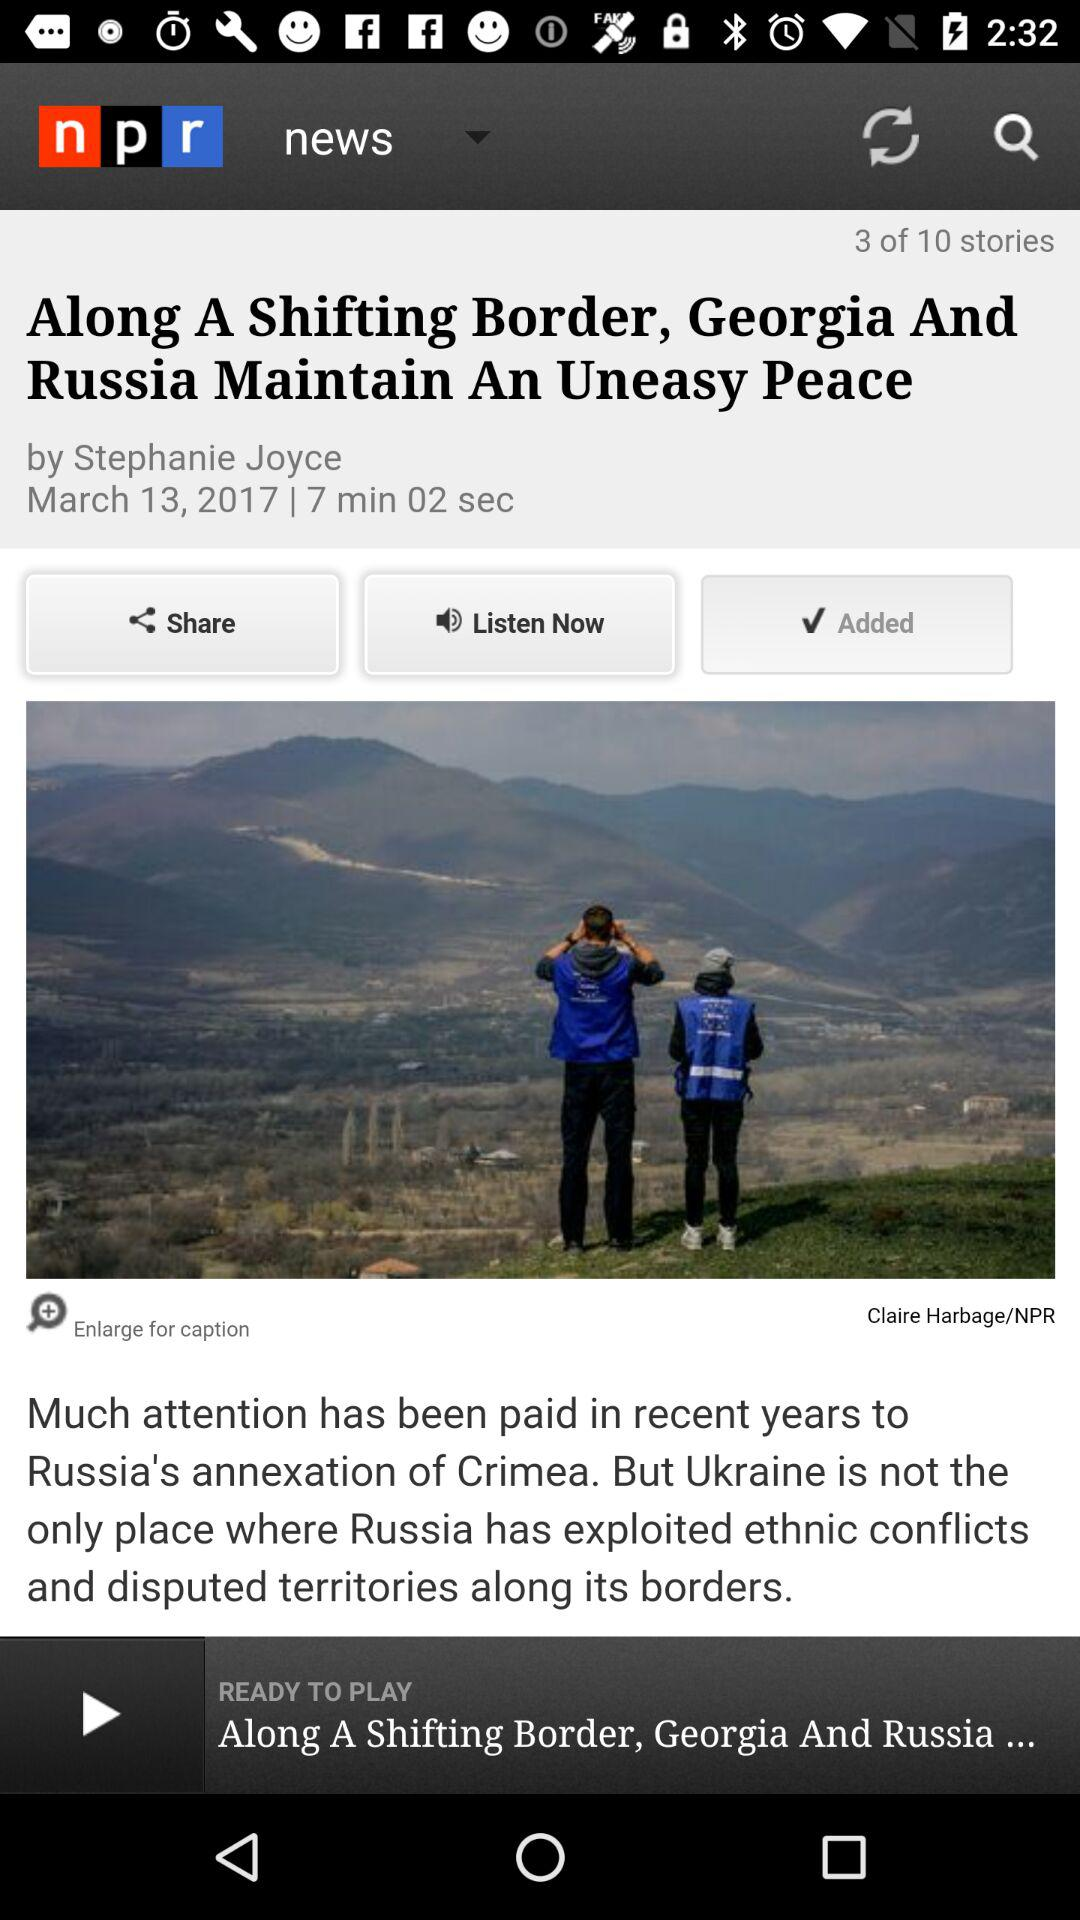Who is the writer of the story? The writer of the story is Stephanie Joyce. 